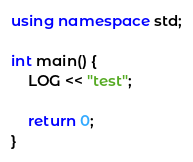Convert code to text. <code><loc_0><loc_0><loc_500><loc_500><_C++_>
using namespace std;

int main() {
    LOG << "test";

    return 0;
}</code> 